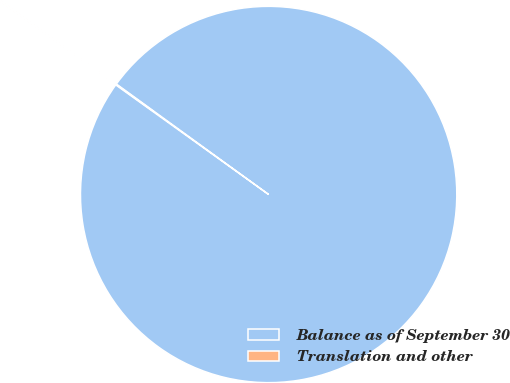Convert chart to OTSL. <chart><loc_0><loc_0><loc_500><loc_500><pie_chart><fcel>Balance as of September 30<fcel>Translation and other<nl><fcel>99.91%<fcel>0.09%<nl></chart> 